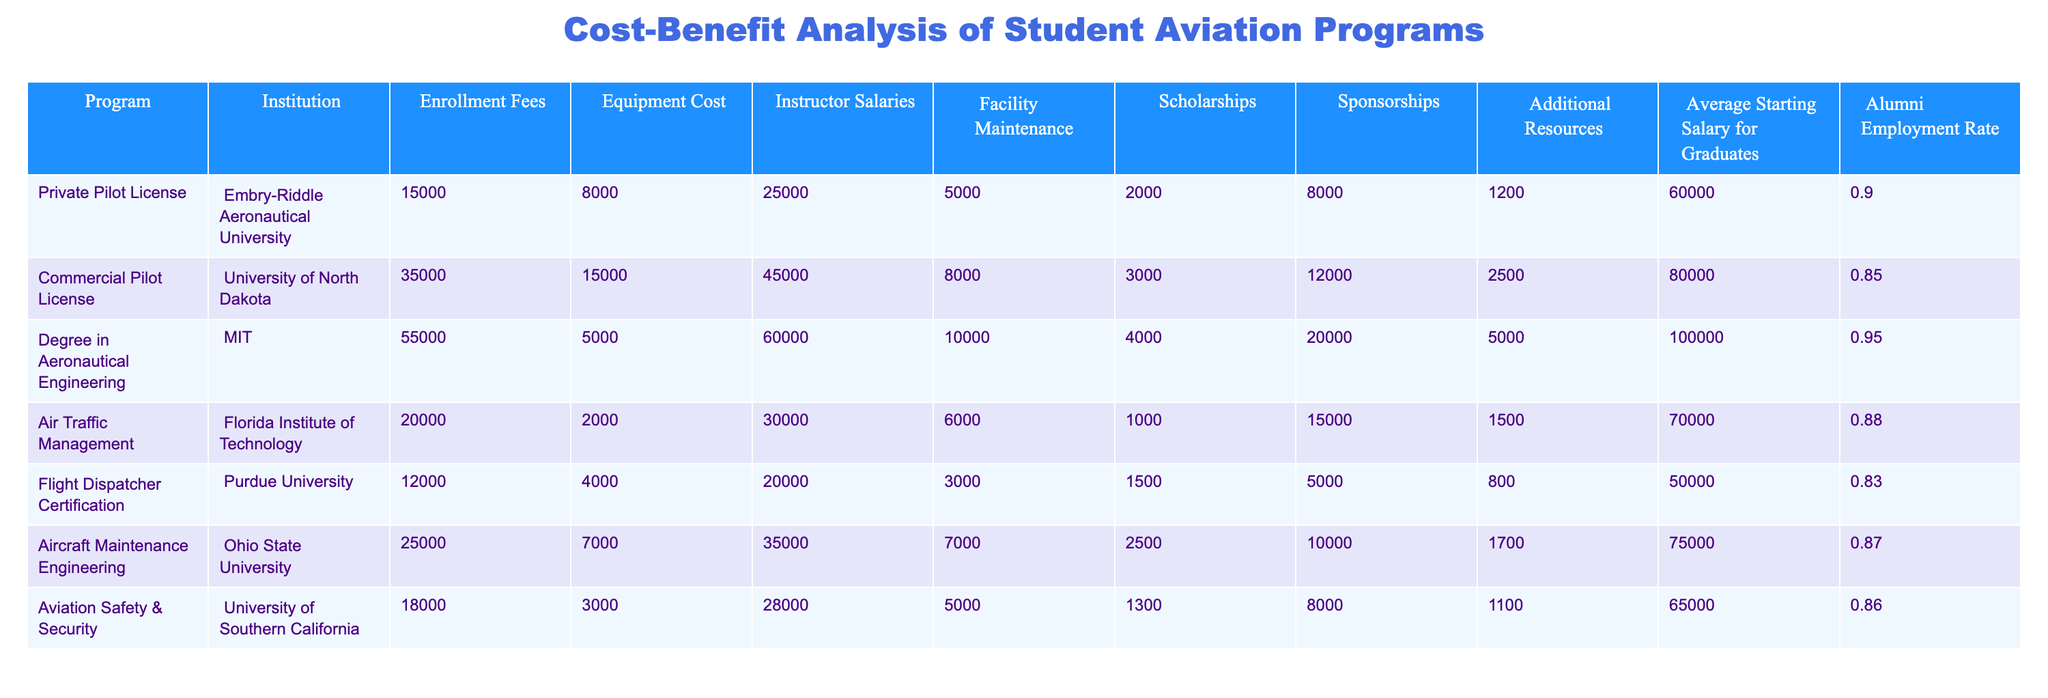What is the enrollment fee for the Degree in Aeronautical Engineering program? The table shows that the enrollment fee for the Degree in Aeronautical Engineering program at MIT is listed directly as 55000.
Answer: 55000 Which program has the highest average starting salary for graduates? By comparing the average starting salaries for graduates across all programs, the Degree in Aeronautical Engineering has the highest at 100000.
Answer: 100000 What is the total cost that students would incur for the Commercial Pilot License program, including all fees and costs? For the Commercial Pilot License at the University of North Dakota, we sum up the Enrollment Fees (35000), Equipment Cost (15000), Instructor Salaries (45000), and Facility Maintenance (8000), which totals to 35000 + 15000 + 45000 + 8000 = 103000.
Answer: 103000 Is there a program with an alumni employment rate of 90% or higher? According to the table, the Degree in Aeronautical Engineering program has an alumni employment rate of 0.95, which is 95%, and the Private Pilot License program has an alumni employment rate of 0.90, confirming that both have employment rates of 90% or higher.
Answer: Yes What is the difference between the total equipment cost for the Flight Dispatcher Certification and the Aircraft Maintenance Engineering programs? The table shows the Equipment Cost for the Flight Dispatcher Certification at Purdue University is 4000 and for the Aircraft Maintenance Engineering at Ohio State University is 7000. The difference is calculated as 7000 - 4000 = 3000.
Answer: 3000 What is the total amount received from scholarships for the Aviation Safety & Security program? The table indicates that the amount of scholarships for the Aviation Safety & Security program at the University of Southern California is directly listed as 1300.
Answer: 1300 Which program has the least amount spent on instructor salaries? By looking at the Instructor Salaries column, we see the Flight Dispatcher Certification program has the lowest cost at 20000 when compared to the other programs.
Answer: 20000 What is the average alumni employment rate for programs with starting salaries of 70000 or higher? The programs with starting salaries of 70000 or higher are: Commercial Pilot License (0.85), Degree in Aeronautical Engineering (0.95), and Aircraft Maintenance Engineering (0.87). The average is (0.85 + 0.95 + 0.87) / 3 = 0.89.
Answer: 0.89 